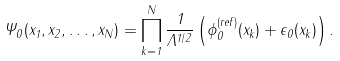<formula> <loc_0><loc_0><loc_500><loc_500>\Psi _ { 0 } ( x _ { 1 } , x _ { 2 } , \dots , x _ { N } ) = \prod _ { k = 1 } ^ { N } \frac { 1 } { \Lambda ^ { 1 / 2 } } \left ( \phi _ { 0 } ^ { ( r e f ) } ( x _ { k } ) + \epsilon _ { 0 } ( x _ { k } ) \right ) .</formula> 